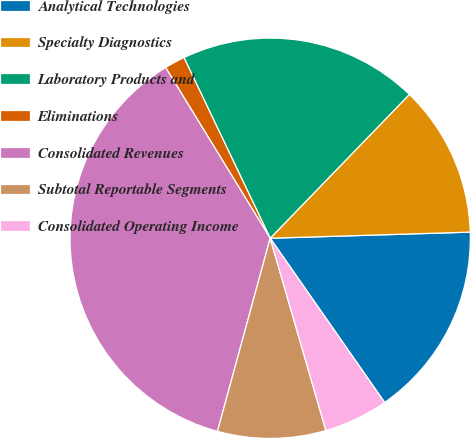<chart> <loc_0><loc_0><loc_500><loc_500><pie_chart><fcel>Analytical Technologies<fcel>Specialty Diagnostics<fcel>Laboratory Products and<fcel>Eliminations<fcel>Consolidated Revenues<fcel>Subtotal Reportable Segments<fcel>Consolidated Operating Income<nl><fcel>15.8%<fcel>12.27%<fcel>19.33%<fcel>1.66%<fcel>37.01%<fcel>8.73%<fcel>5.2%<nl></chart> 